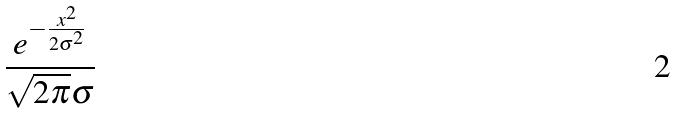<formula> <loc_0><loc_0><loc_500><loc_500>\frac { e ^ { - \frac { x ^ { 2 } } { 2 \sigma ^ { 2 } } } } { \sqrt { 2 \pi } \sigma }</formula> 